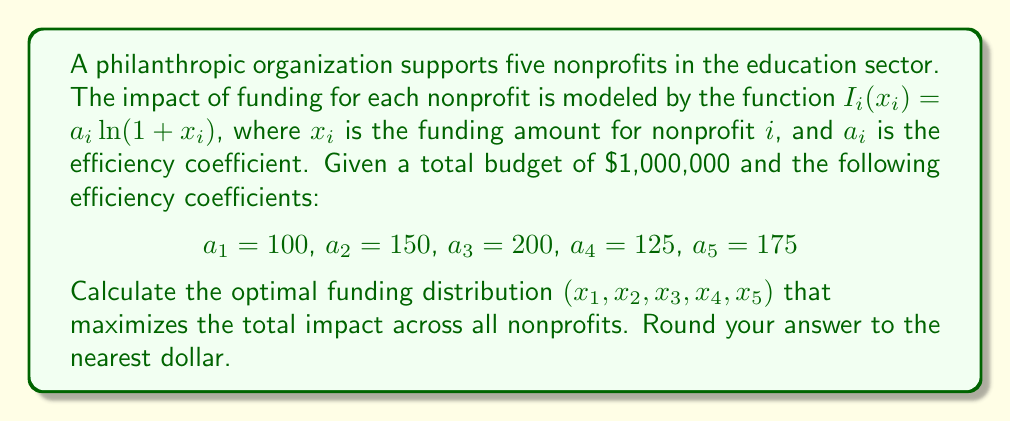Teach me how to tackle this problem. To solve this problem, we'll use the method of Lagrange multipliers, as this is an optimization problem with constraints.

1) First, we define the objective function as the sum of individual impact functions:

   $$f(x_1, x_2, x_3, x_4, x_5) = \sum_{i=1}^5 I_i(x_i) = \sum_{i=1}^5 a_i \ln(1 + x_i)$$

2) The constraint is that the sum of all funding amounts equals the total budget:

   $$g(x_1, x_2, x_3, x_4, x_5) = x_1 + x_2 + x_3 + x_4 + x_5 - 1000000 = 0$$

3) We form the Lagrangian:

   $$L(x_1, x_2, x_3, x_4, x_5, \lambda) = f(x_1, x_2, x_3, x_4, x_5) - \lambda g(x_1, x_2, x_3, x_4, x_5)$$

4) We take partial derivatives and set them to zero:

   $$\frac{\partial L}{\partial x_i} = \frac{a_i}{1 + x_i} - \lambda = 0$$
   $$\frac{\partial L}{\partial \lambda} = x_1 + x_2 + x_3 + x_4 + x_5 - 1000000 = 0$$

5) From the first equation, we get:

   $$x_i = \frac{a_i}{\lambda} - 1$$

6) Substituting this into the constraint equation:

   $$\sum_{i=1}^5 (\frac{a_i}{\lambda} - 1) = 1000000$$
   $$\frac{1}{\lambda} \sum_{i=1}^5 a_i - 5 = 1000000$$
   $$\frac{1}{\lambda} (100 + 150 + 200 + 125 + 175) - 5 = 1000000$$
   $$\frac{750}{\lambda} = 1000005$$
   $$\lambda = \frac{750}{1000005} \approx 0.00074999625$$

7) Now we can calculate each $x_i$:

   $$x_1 = \frac{100}{0.00074999625} - 1 \approx 133333$$
   $$x_2 = \frac{150}{0.00074999625} - 1 \approx 200000$$
   $$x_3 = \frac{200}{0.00074999625} - 1 \approx 266667$$
   $$x_4 = \frac{125}{0.00074999625} - 1 \approx 166666$$
   $$x_5 = \frac{175}{0.00074999625} - 1 \approx 233333$$

8) Rounding to the nearest dollar gives us our final answer.
Answer: The optimal funding distribution (rounded to the nearest dollar) is:

$x_1 = \$133,333$
$x_2 = \$200,000$
$x_3 = \$266,667$
$x_4 = \$166,667$
$x_5 = \$233,333$ 